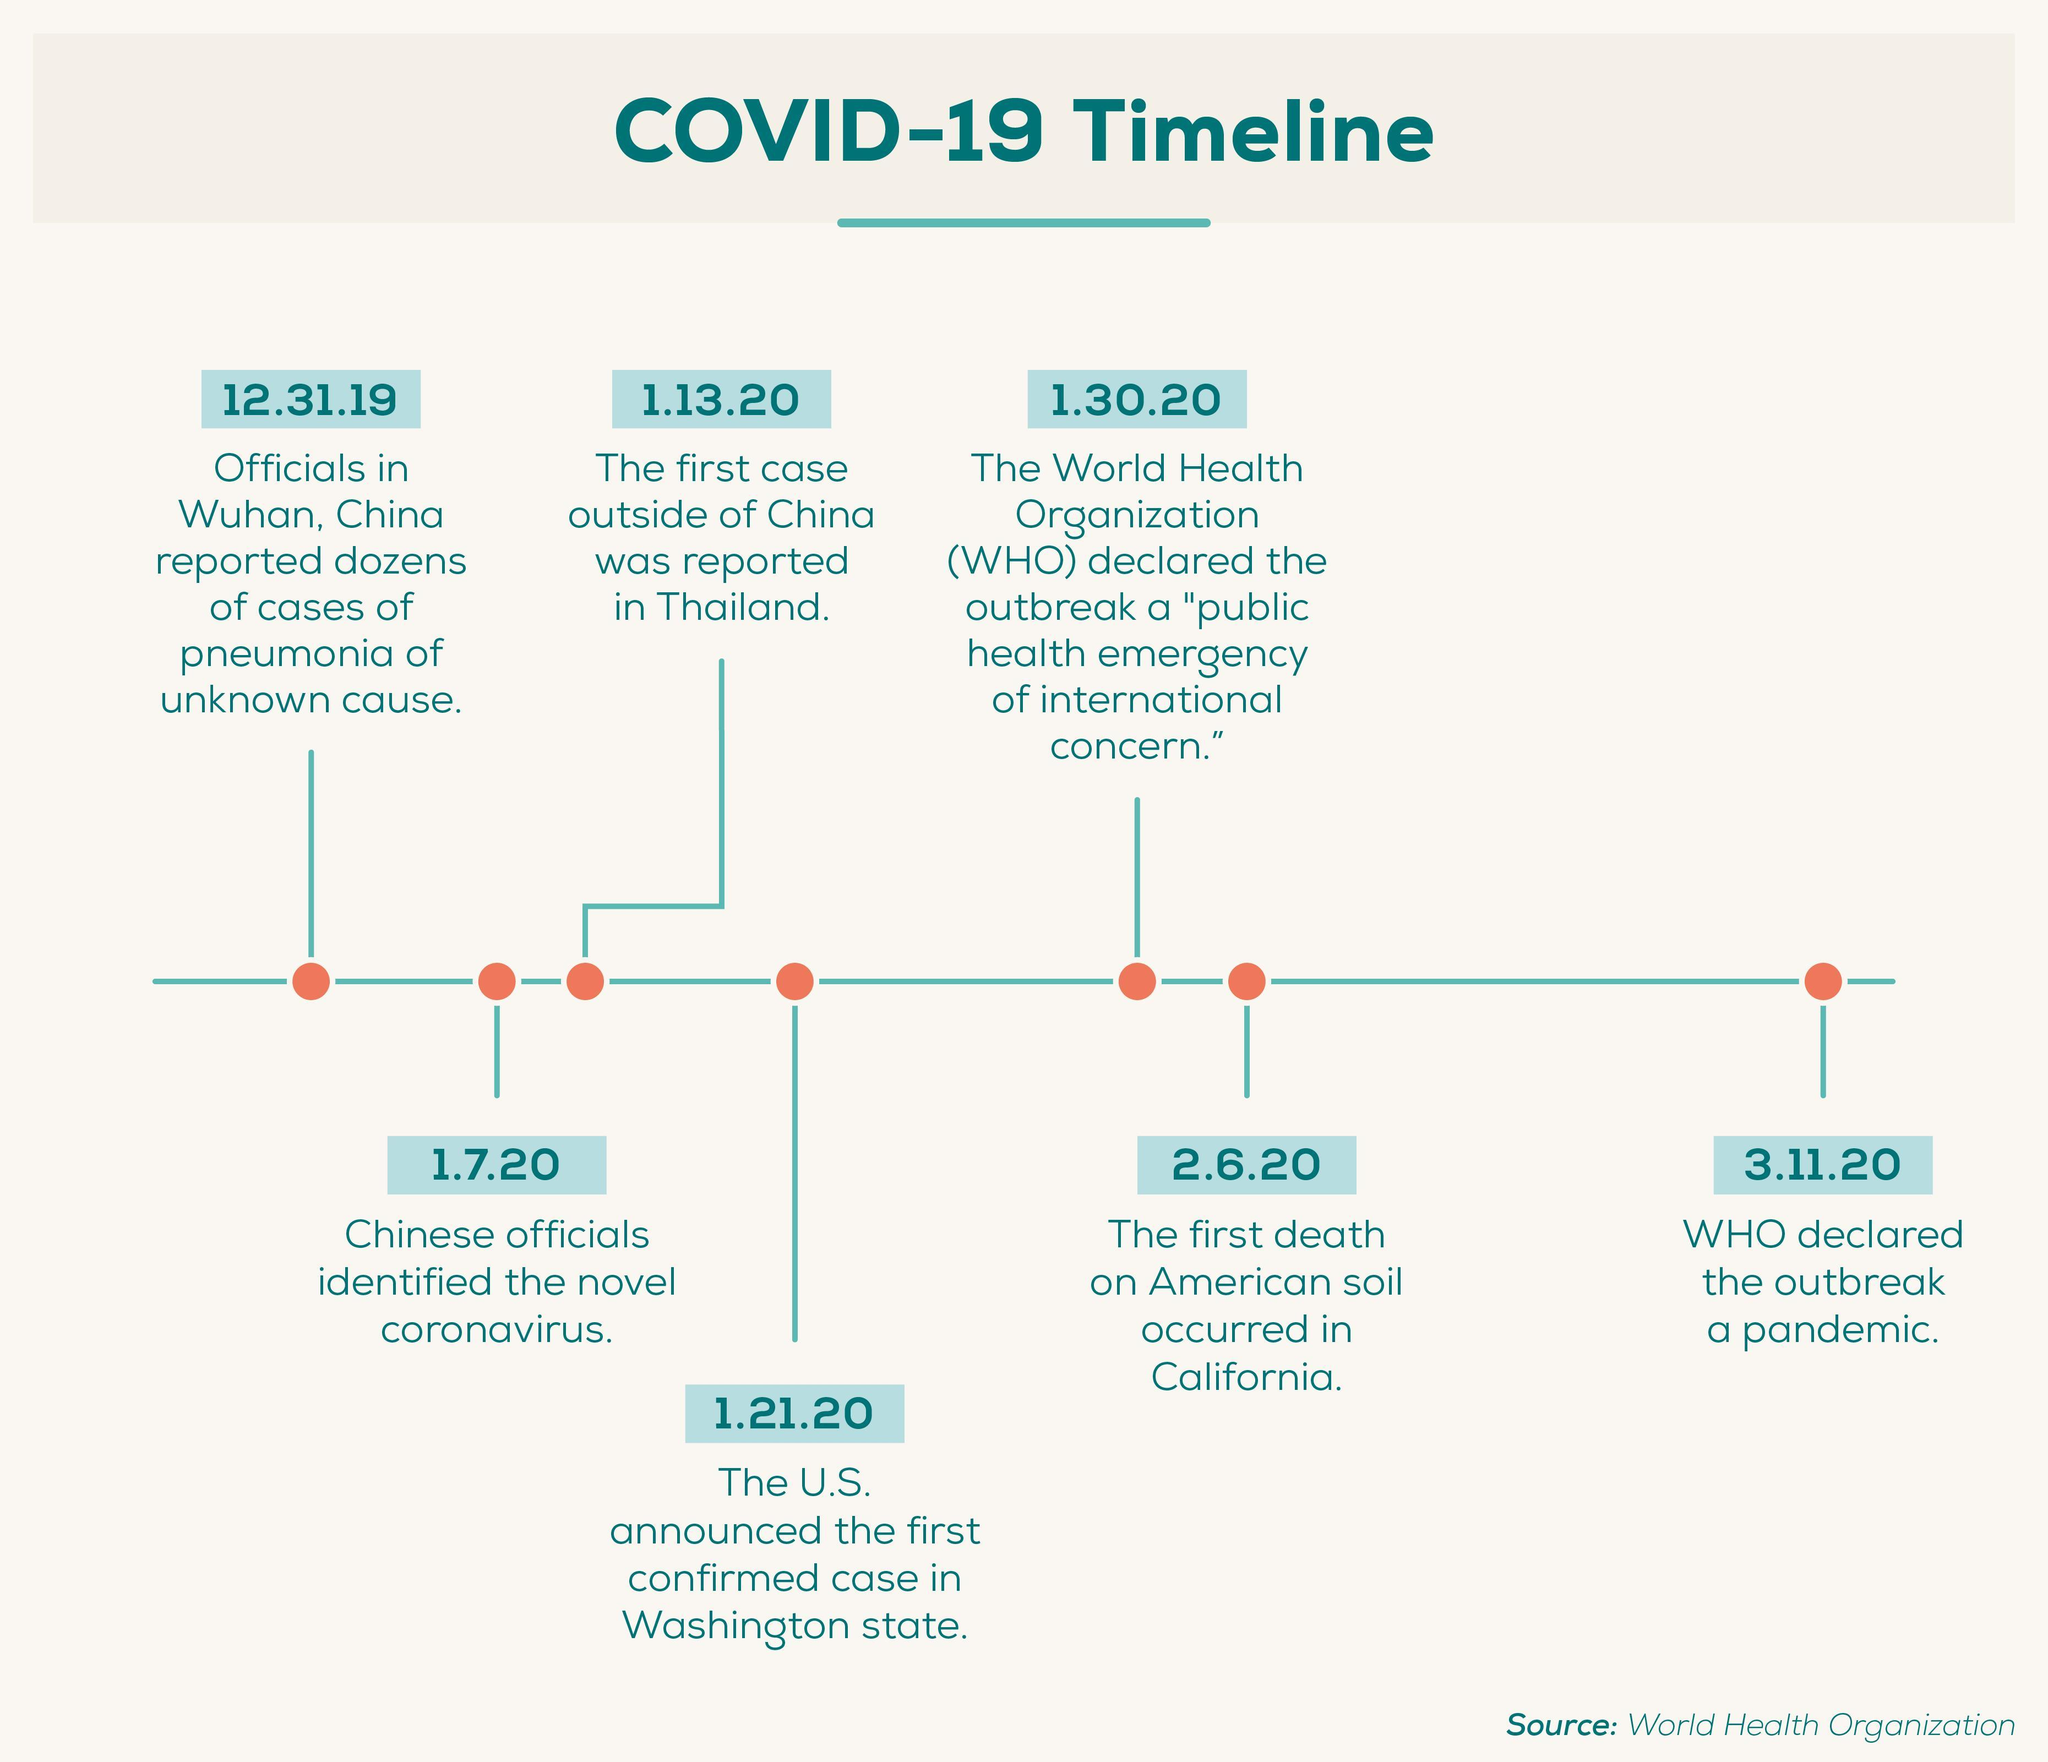Where was the first case of COVID-19 reported outside of china?
Answer the question with a short phrase. in Thailand. When did WHO declared COVID-19 as a pandemic? 3.11.20 When did the chinese officials identified the novel coronavirus? 1.7.20 